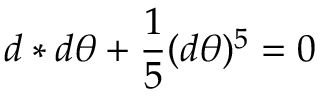<formula> <loc_0><loc_0><loc_500><loc_500>d * d \theta + \frac { 1 } { 5 } ( d \theta ) ^ { 5 } = 0</formula> 